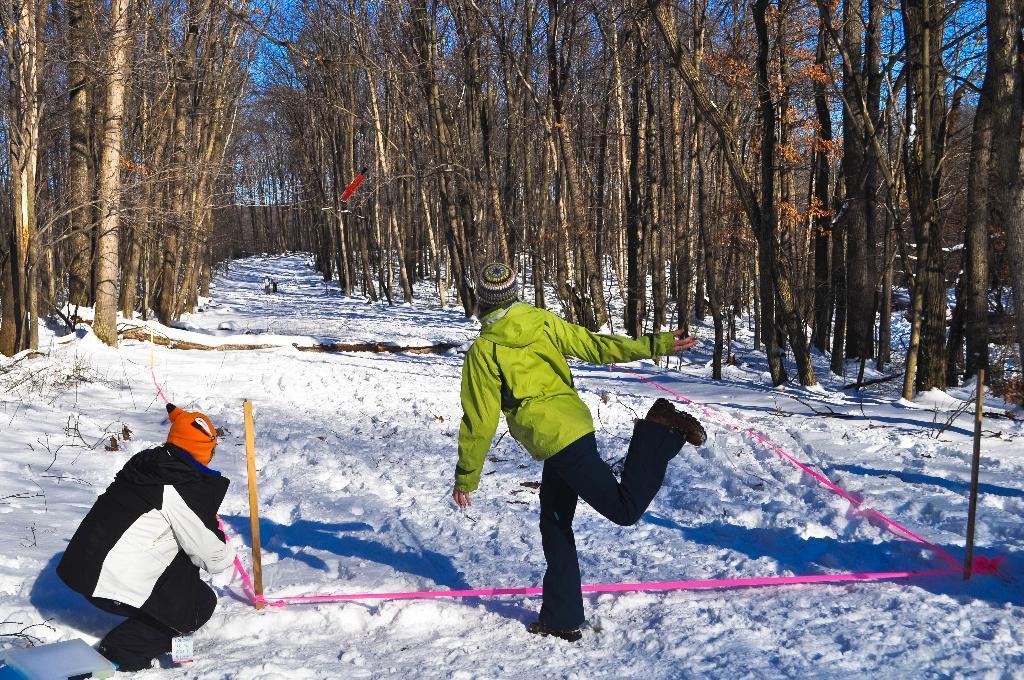How would you summarize this image in a sentence or two? Here in this picture we can see two persons present on the ground, which is fully covered with snow over there and we can see both of them are wearing jackets and caps on them and we can see trees present all over there. 